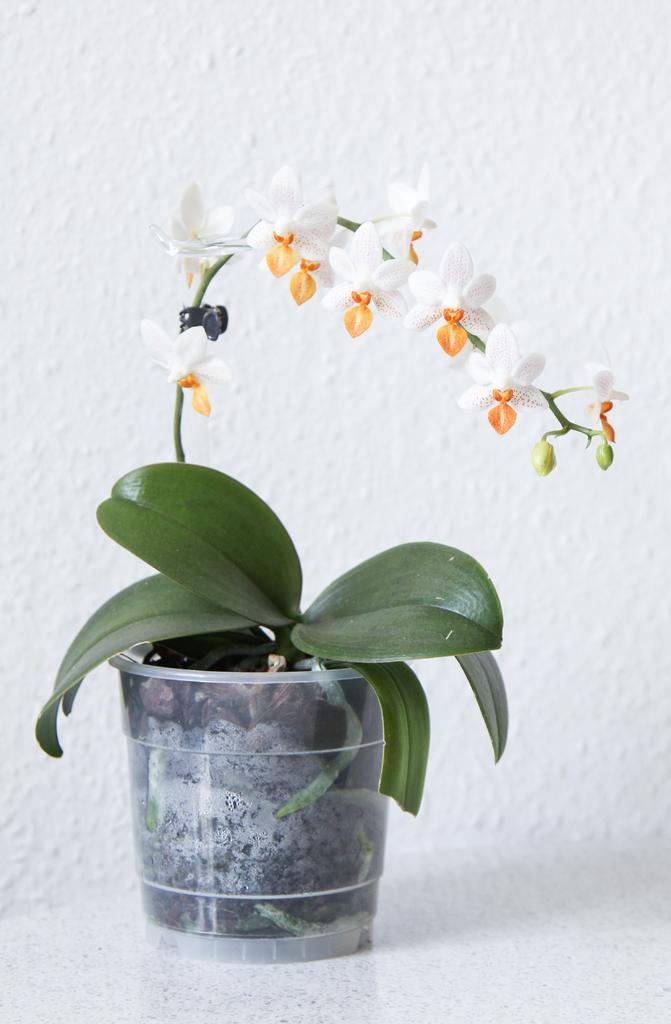What type of plant can be seen in the image? There is a potted plant in the image. What color are the leaves of the potted plant? The potted plant has green leaves. What additional feature can be observed on the potted plant? The potted plant has white flowers. On what surface is the potted plant placed? The potted plant is placed on a surface. What color is the background of the image? The background of the image is white. How many books are stacked next to the potted plant in the image? There are no books present in the image; it only features a potted plant with green leaves and white flowers placed on a surface against a white background. 